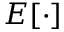Convert formula to latex. <formula><loc_0><loc_0><loc_500><loc_500>E [ \cdot ]</formula> 